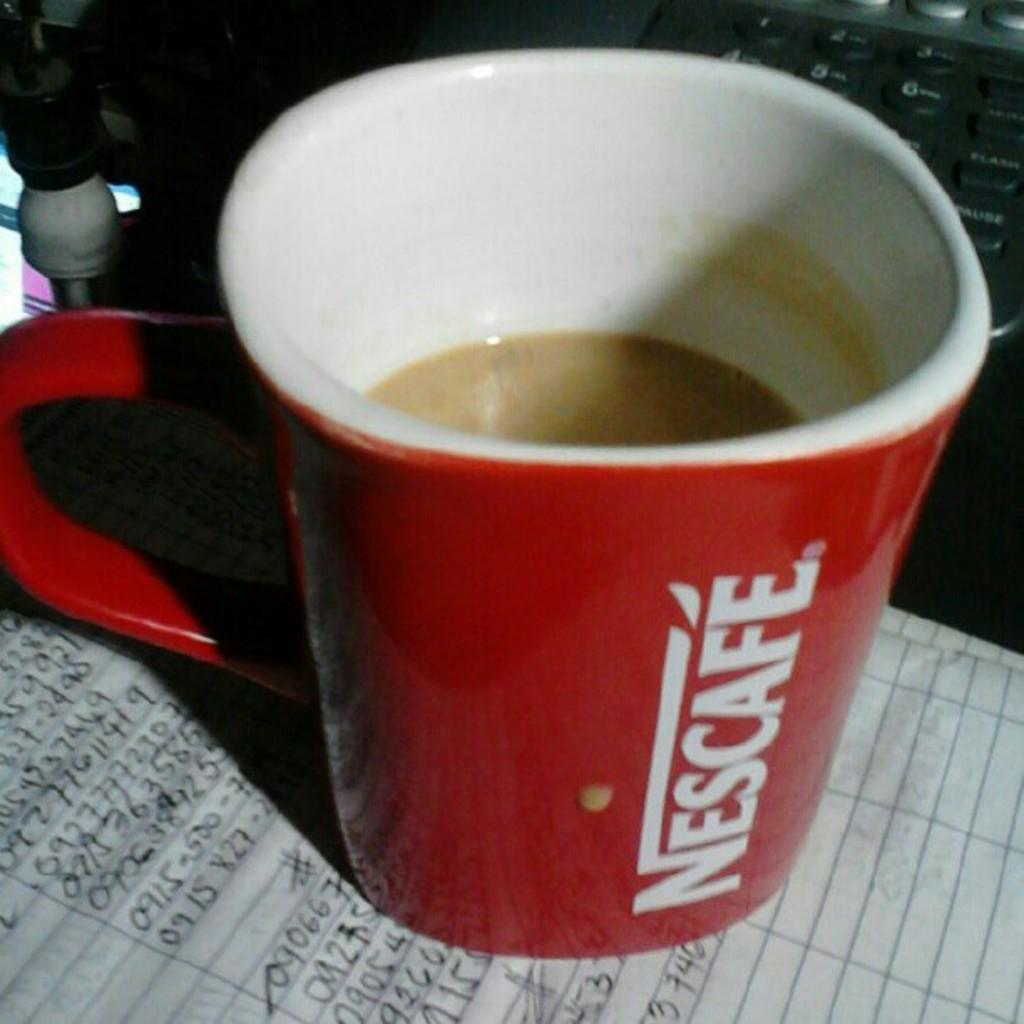<image>
Write a terse but informative summary of the picture. a red cup with the word Nescafe written on it 